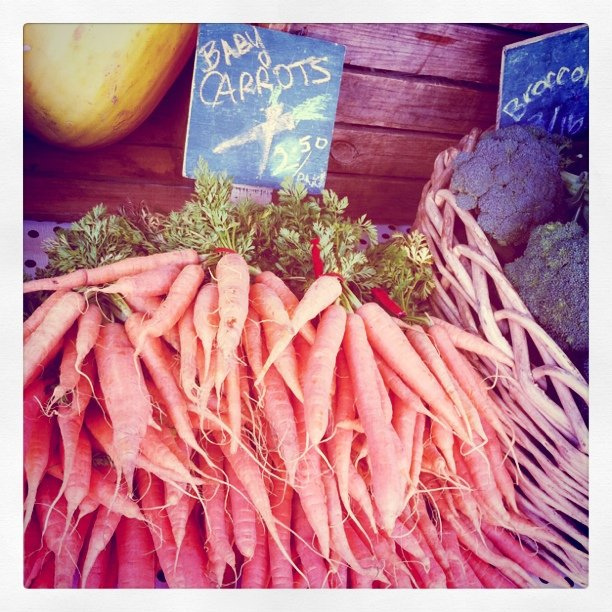Are those carrots organic?
Answer the question using a single word or phrase. No Is this area in a market? Yes What type of carrots are they? Baby 